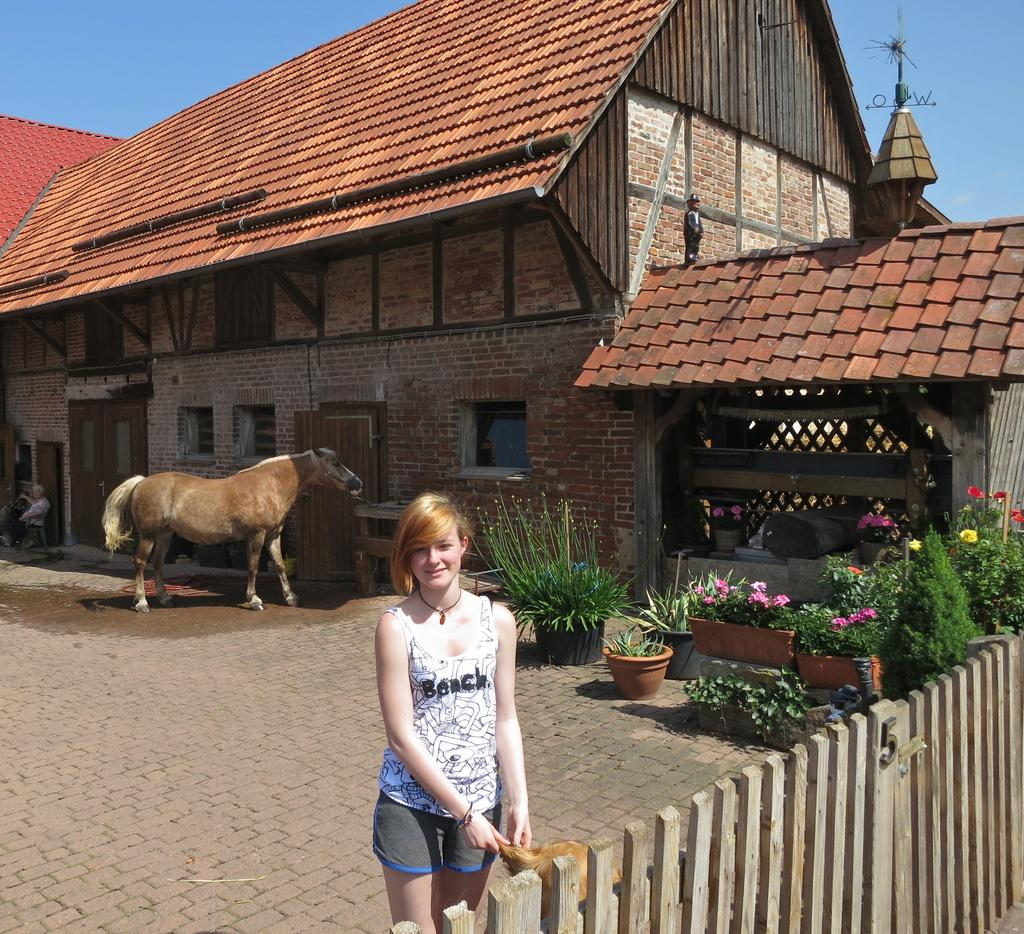What is the woman doing in the image? The woman is standing beside a fence in the image. What is the woman holding in the image? The woman is holding an object in the image. Can you describe the plants in the image? There are plants in pots in the image. What animal is present in the image? There is a horse in the image. What is the position of the person in the image? There is a person sitting in the image. What type of structure is visible in the image? There is a house with a roof in the image. What part of the natural environment is visible in the image? The sky is visible in the image. Can you tell me how many bikes are parked near the fence in the image? There is no bike present in the image; only a woman, a fence, plants in pots, a horse, a person sitting, a house with a roof, and the sky are visible. Where is the kitty located in the image? There is no kitty present in the image. 